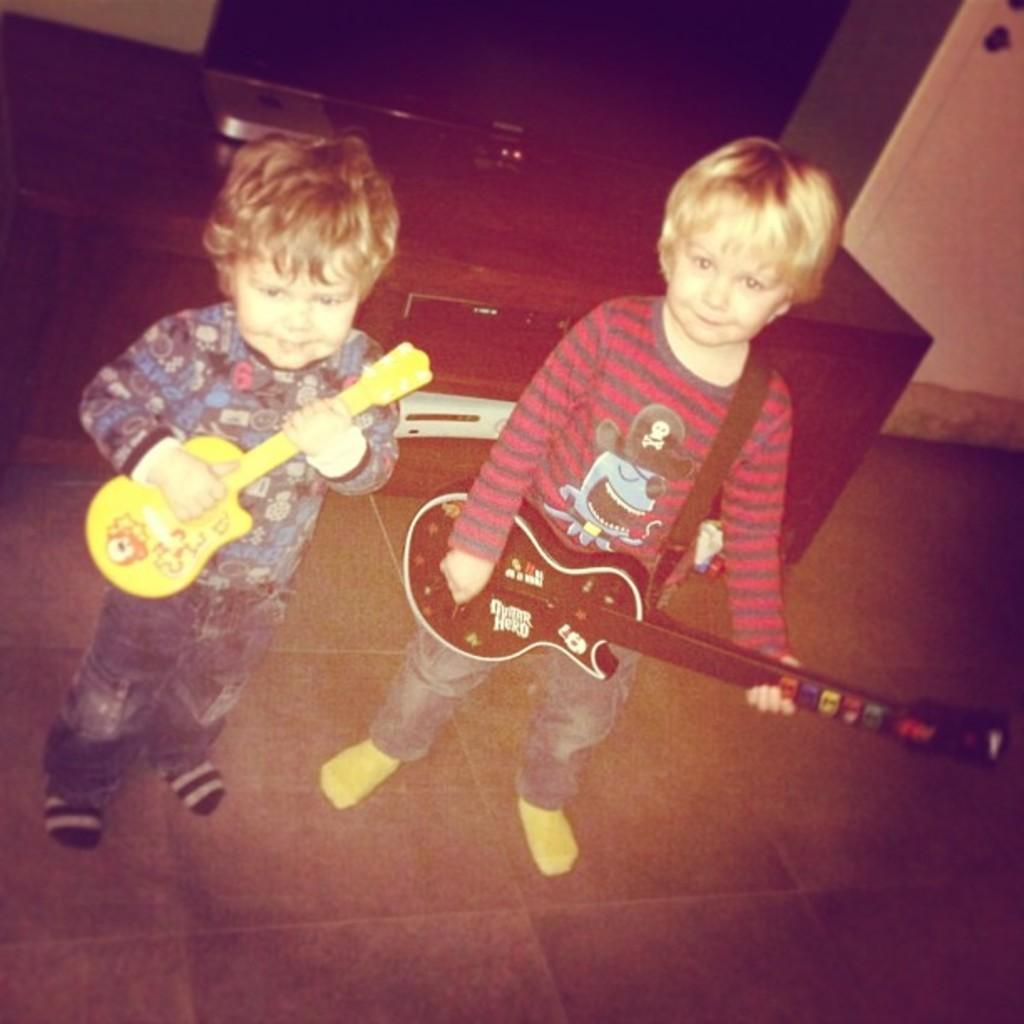How many kids are in the image? There are two kids in the image. What are the kids holding in the image? The kids are holding a guitar. What can be seen in the background of the image? There is a television on a table in the background. What type of animals can be seen at the zoo in the image? There is no zoo present in the image, so it is not possible to determine what, if any, animals might be seen. 